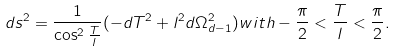<formula> <loc_0><loc_0><loc_500><loc_500>d s ^ { 2 } = \frac { 1 } { \cos ^ { 2 } \frac { T } { l } } ( - d T ^ { 2 } + l ^ { 2 } d \Omega _ { d - 1 } ^ { 2 } ) w i t h - \frac { \pi } { 2 } < \frac { T } { l } < \frac { \pi } { 2 } .</formula> 